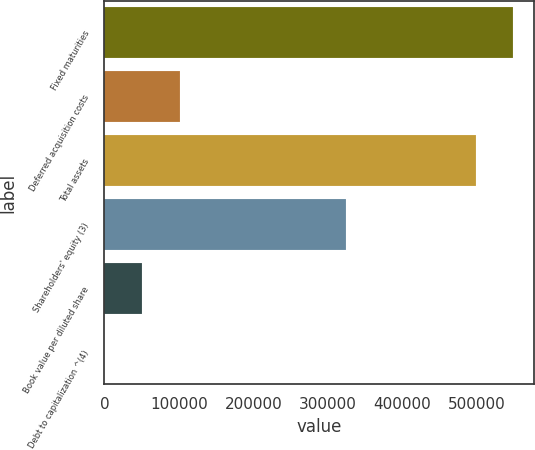<chart> <loc_0><loc_0><loc_500><loc_500><bar_chart><fcel>Fixed maturities<fcel>Deferred acquisition costs<fcel>Total assets<fcel>Shareholders' equity (3)<fcel>Book value per diluted share<fcel>Debt to capitalization ^(4)<nl><fcel>548899<fcel>101232<fcel>498284<fcel>323885<fcel>50616.7<fcel>1.5<nl></chart> 